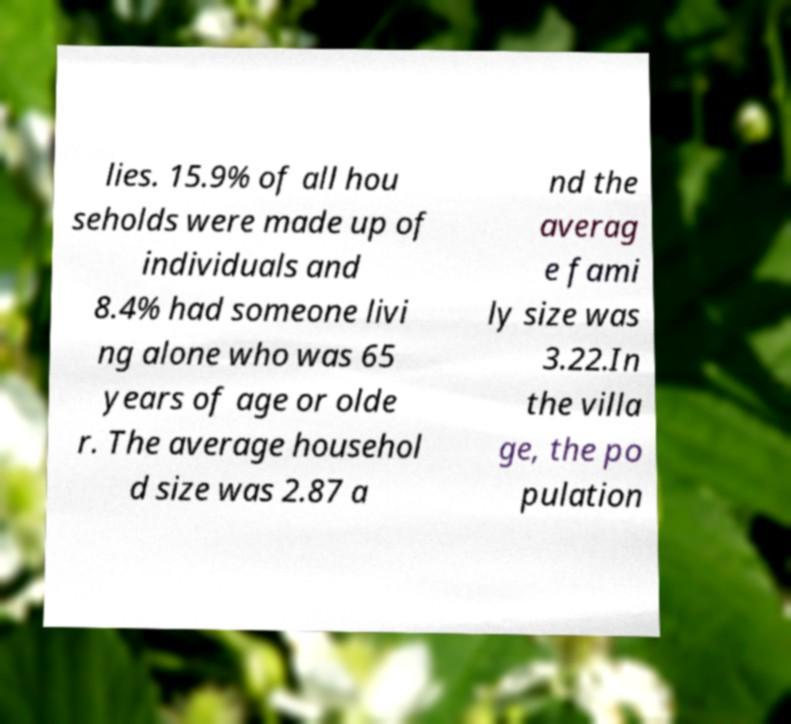Can you accurately transcribe the text from the provided image for me? lies. 15.9% of all hou seholds were made up of individuals and 8.4% had someone livi ng alone who was 65 years of age or olde r. The average househol d size was 2.87 a nd the averag e fami ly size was 3.22.In the villa ge, the po pulation 